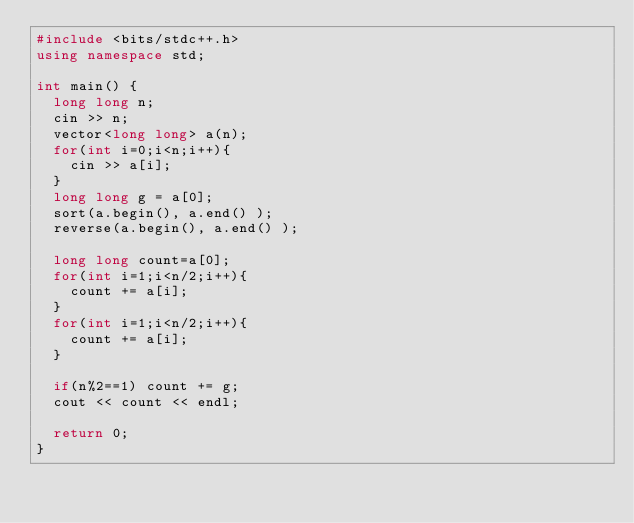<code> <loc_0><loc_0><loc_500><loc_500><_C++_>#include <bits/stdc++.h>
using namespace std;

int main() {
  long long n;
  cin >> n;
  vector<long long> a(n);
  for(int i=0;i<n;i++){
    cin >> a[i];
  }
  long long g = a[0];
  sort(a.begin(), a.end() );
  reverse(a.begin(), a.end() );
  
  long long count=a[0];
  for(int i=1;i<n/2;i++){
    count += a[i];
  }
  for(int i=1;i<n/2;i++){
    count += a[i];
  }
  
  if(n%2==1) count += g;
  cout << count << endl;
  
  return 0;
}
</code> 